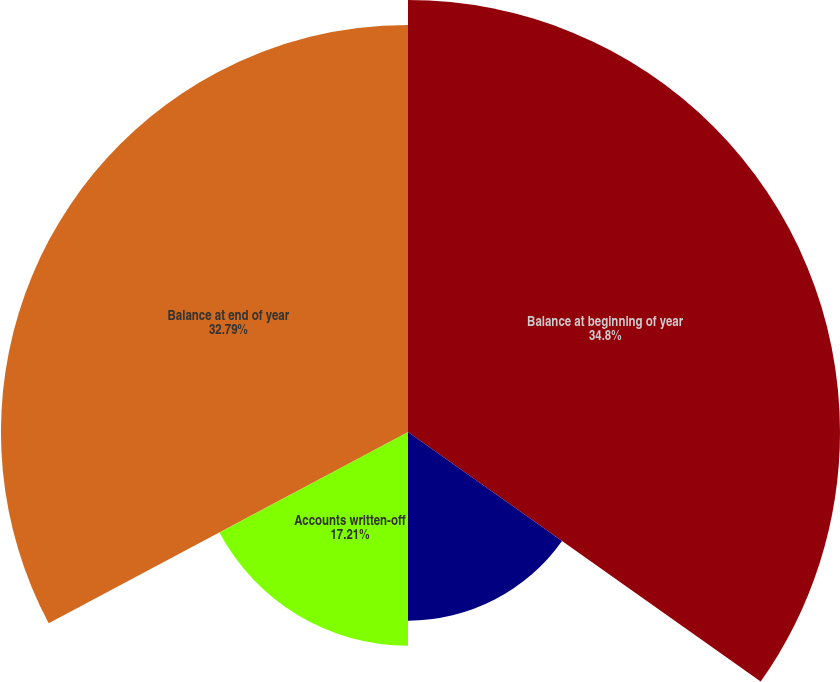Convert chart to OTSL. <chart><loc_0><loc_0><loc_500><loc_500><pie_chart><fcel>Balance at beginning of year<fcel>Additions charged to expense<fcel>Accounts written-off<fcel>Balance at end of year<nl><fcel>34.8%<fcel>15.2%<fcel>17.21%<fcel>32.79%<nl></chart> 